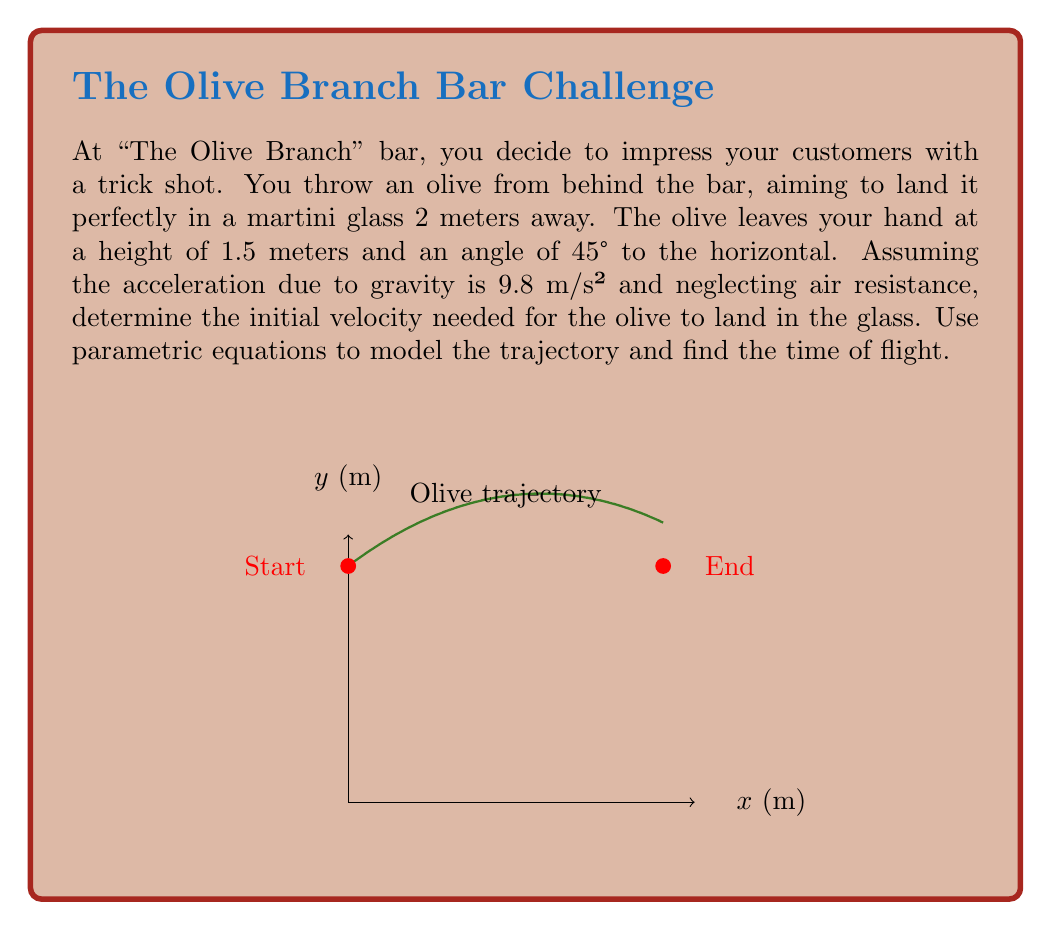Can you answer this question? Let's approach this step-by-step using parametric equations:

1) The parametric equations for projectile motion are:
   $$x(t) = v_0 \cos(\theta) t$$
   $$y(t) = v_0 \sin(\theta) t - \frac{1}{2}gt^2 + y_0$$

   Where $v_0$ is the initial velocity, $\theta$ is the launch angle, $g$ is the acceleration due to gravity, and $y_0$ is the initial height.

2) We know:
   $\theta = 45°$, $g = 9.8$ m/s², $y_0 = 1.5$ m, and the target is at $(x,y) = (2, 1.5)$

3) At the target point, we can write:
   $$2 = v_0 \cos(45°) t$$
   $$1.5 = v_0 \sin(45°) t - \frac{1}{2}(9.8)t^2 + 1.5$$

4) From the second equation:
   $$0 = v_0 \sin(45°) t - 4.9t^2$$

5) We know that $\sin(45°) = \cos(45°) = \frac{1}{\sqrt{2}}$, so from the first equation:
   $$t = \frac{2\sqrt{2}}{v_0}$$

6) Substituting this into the equation from step 4:
   $$0 = v_0 \cdot \frac{1}{\sqrt{2}} \cdot \frac{2\sqrt{2}}{v_0} - 4.9 \cdot (\frac{2\sqrt{2}}{v_0})^2$$

7) Simplifying:
   $$0 = 2 - 4.9 \cdot \frac{8}{v_0^2}$$
   $$39.2 = v_0^2$$
   $$v_0 = \sqrt{39.2} \approx 6.26 \text{ m/s}$$

8) To find the time of flight, we can use the equation from step 5:
   $$t = \frac{2\sqrt{2}}{6.26} \approx 0.45 \text{ seconds}$$
Answer: Initial velocity: $6.26$ m/s, Time of flight: $0.45$ s 